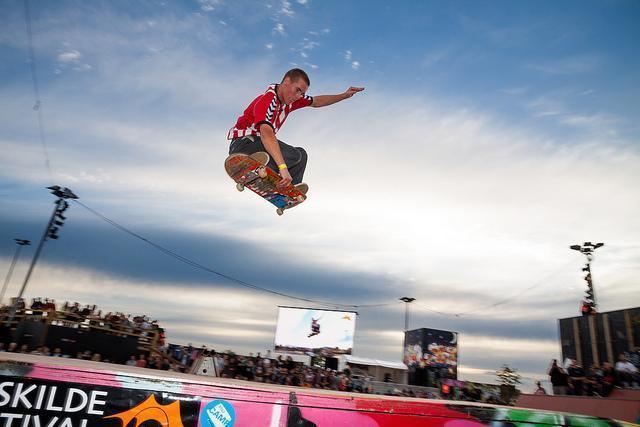What is the name of the trick the man in red is performing?
Select the accurate response from the four choices given to answer the question.
Options: Manual, grab, fakie, grind. Grab. 